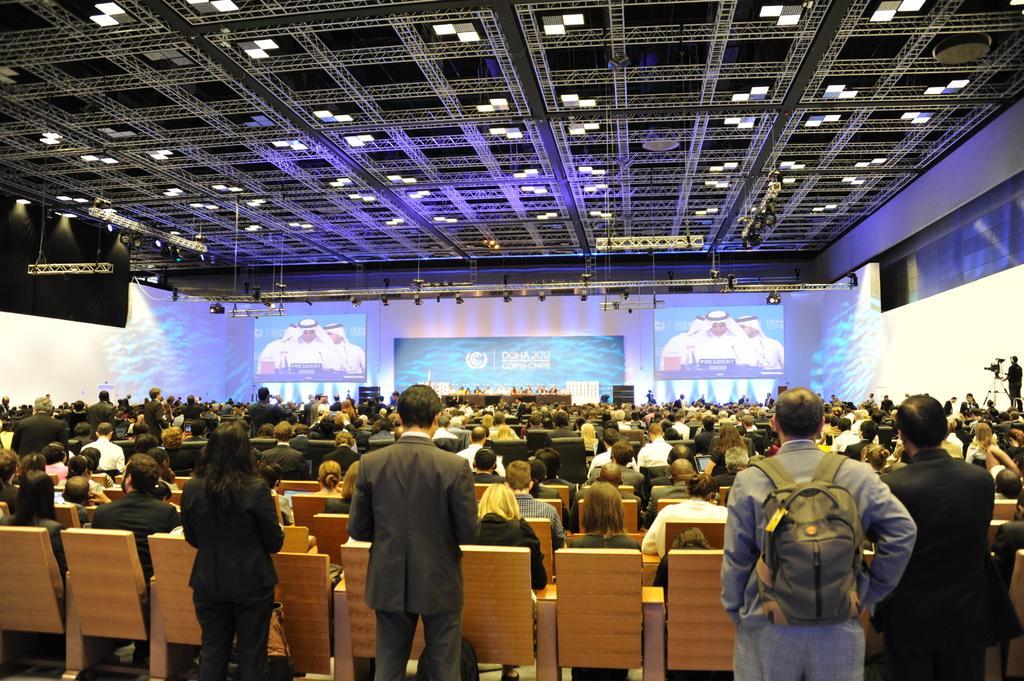Please provide a concise description of this image. In the image in the center we can see four people were standing and holding some objects. In the background there is a roof,screen,table,stage,lights,cameras,banners,group of people were sitting on the chair and few other objects. 